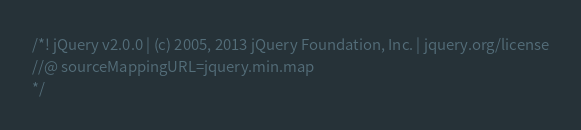Convert code to text. <code><loc_0><loc_0><loc_500><loc_500><_JavaScript_>/*! jQuery v2.0.0 | (c) 2005, 2013 jQuery Foundation, Inc. | jquery.org/license
//@ sourceMappingURL=jquery.min.map
*/</code> 